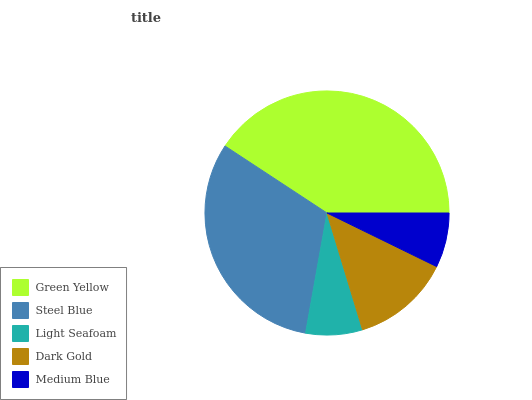Is Medium Blue the minimum?
Answer yes or no. Yes. Is Green Yellow the maximum?
Answer yes or no. Yes. Is Steel Blue the minimum?
Answer yes or no. No. Is Steel Blue the maximum?
Answer yes or no. No. Is Green Yellow greater than Steel Blue?
Answer yes or no. Yes. Is Steel Blue less than Green Yellow?
Answer yes or no. Yes. Is Steel Blue greater than Green Yellow?
Answer yes or no. No. Is Green Yellow less than Steel Blue?
Answer yes or no. No. Is Dark Gold the high median?
Answer yes or no. Yes. Is Dark Gold the low median?
Answer yes or no. Yes. Is Medium Blue the high median?
Answer yes or no. No. Is Medium Blue the low median?
Answer yes or no. No. 